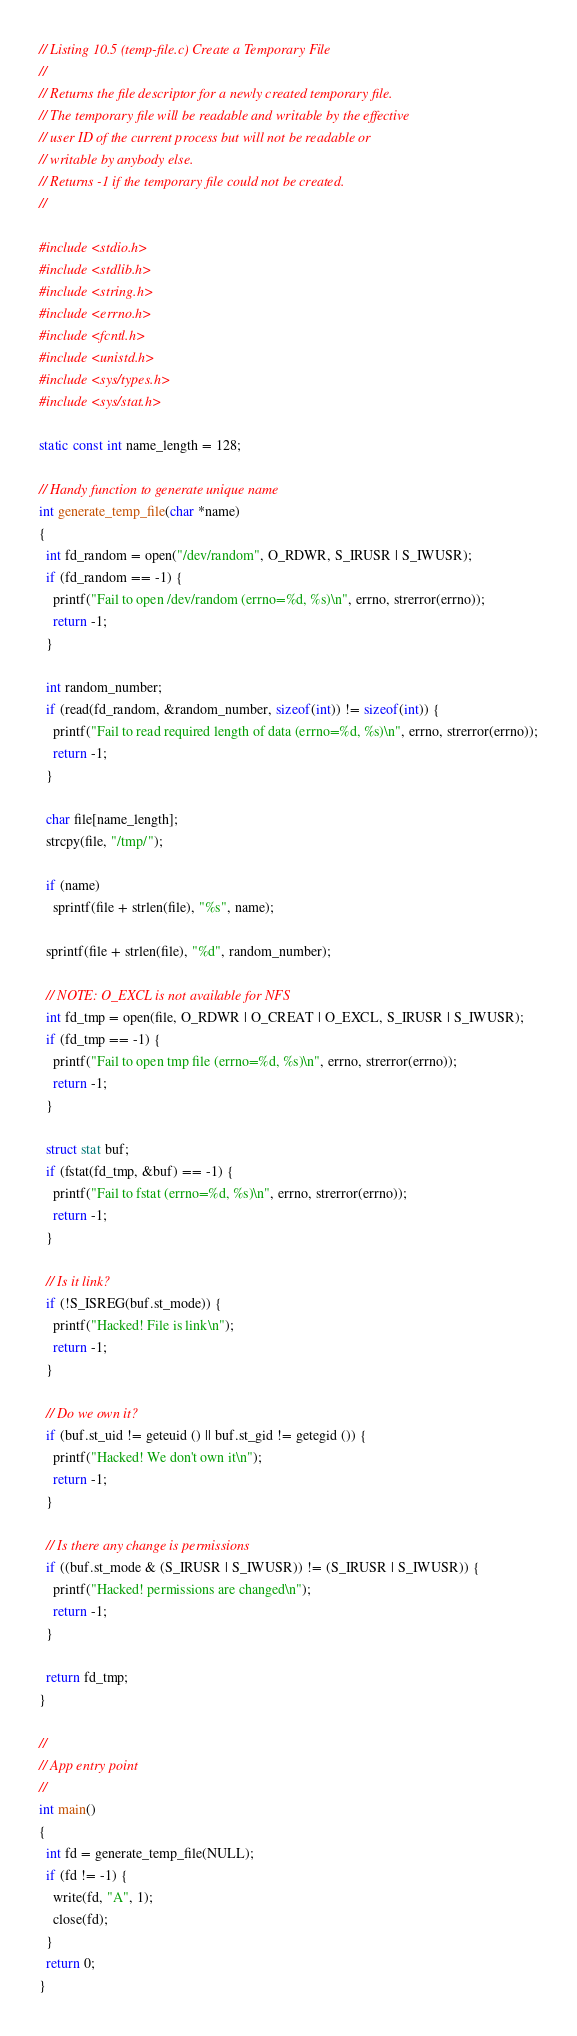<code> <loc_0><loc_0><loc_500><loc_500><_C_>// Listing 10.5 (temp-file.c) Create a Temporary File
//
// Returns the file descriptor for a newly created temporary file.
// The temporary file will be readable and writable by the effective
// user ID of the current process but will not be readable or
// writable by anybody else.
// Returns -1 if the temporary file could not be created.
//

#include <stdio.h>
#include <stdlib.h>
#include <string.h>
#include <errno.h>
#include <fcntl.h>
#include <unistd.h>
#include <sys/types.h>
#include <sys/stat.h>

static const int name_length = 128;

// Handy function to generate unique name
int generate_temp_file(char *name)
{
  int fd_random = open("/dev/random", O_RDWR, S_IRUSR | S_IWUSR);
  if (fd_random == -1) {
    printf("Fail to open /dev/random (errno=%d, %s)\n", errno, strerror(errno));
    return -1;
  }

  int random_number;
  if (read(fd_random, &random_number, sizeof(int)) != sizeof(int)) {
    printf("Fail to read required length of data (errno=%d, %s)\n", errno, strerror(errno));
    return -1;
  }

  char file[name_length];
  strcpy(file, "/tmp/");

  if (name)
    sprintf(file + strlen(file), "%s", name);

  sprintf(file + strlen(file), "%d", random_number);

  // NOTE: O_EXCL is not available for NFS
  int fd_tmp = open(file, O_RDWR | O_CREAT | O_EXCL, S_IRUSR | S_IWUSR);
  if (fd_tmp == -1) {
    printf("Fail to open tmp file (errno=%d, %s)\n", errno, strerror(errno));
    return -1;
  }

  struct stat buf;
  if (fstat(fd_tmp, &buf) == -1) {
    printf("Fail to fstat (errno=%d, %s)\n", errno, strerror(errno));
    return -1;
  }

  // Is it link?
  if (!S_ISREG(buf.st_mode)) {
    printf("Hacked! File is link\n");
    return -1;
  }

  // Do we own it?
  if (buf.st_uid != geteuid () || buf.st_gid != getegid ()) {
    printf("Hacked! We don't own it\n");
    return -1;
  }

  // Is there any change is permissions
  if ((buf.st_mode & (S_IRUSR | S_IWUSR)) != (S_IRUSR | S_IWUSR)) {
    printf("Hacked! permissions are changed\n");
    return -1;
  }

  return fd_tmp;
}

//
// App entry point
//
int main()
{
  int fd = generate_temp_file(NULL);
  if (fd != -1) {
    write(fd, "A", 1);
    close(fd);
  }
  return 0;
}
</code> 